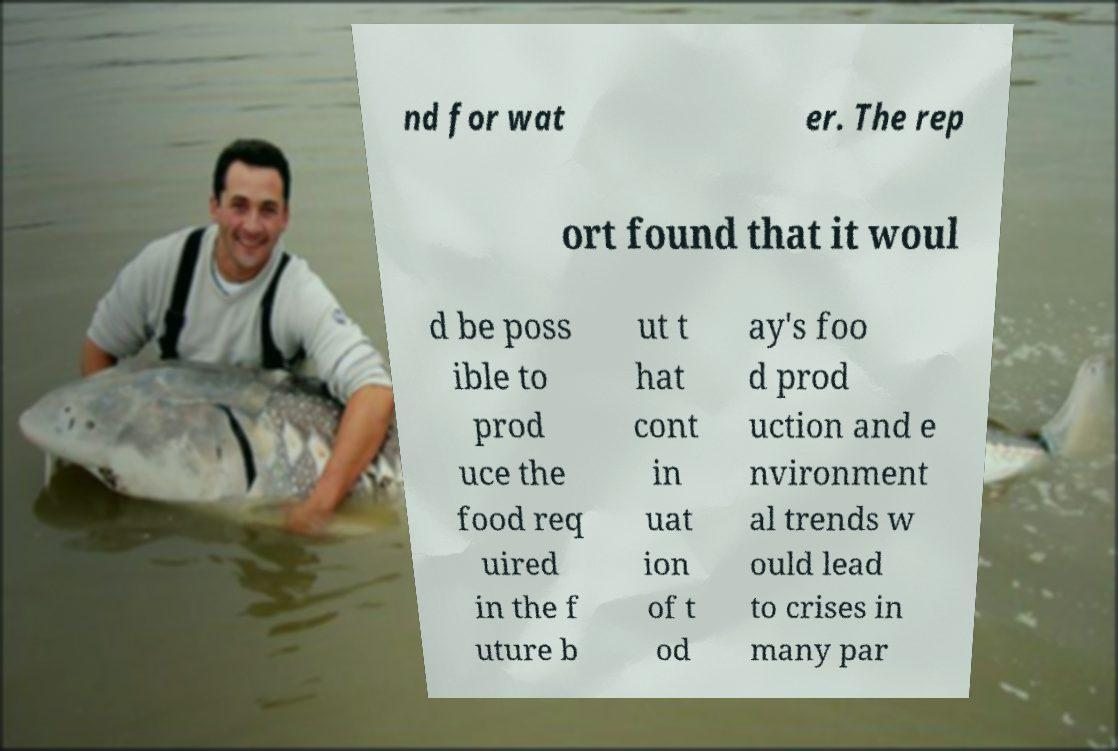Please identify and transcribe the text found in this image. nd for wat er. The rep ort found that it woul d be poss ible to prod uce the food req uired in the f uture b ut t hat cont in uat ion of t od ay's foo d prod uction and e nvironment al trends w ould lead to crises in many par 